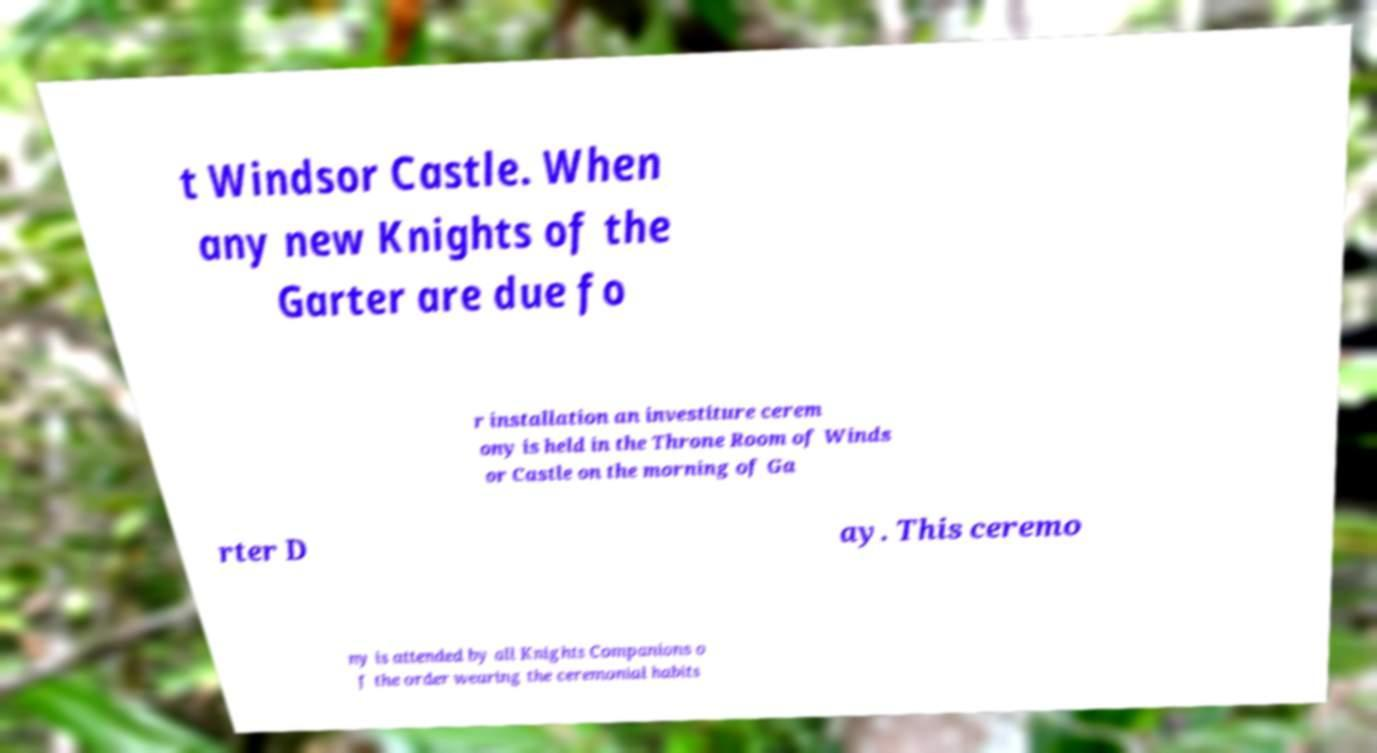Could you extract and type out the text from this image? t Windsor Castle. When any new Knights of the Garter are due fo r installation an investiture cerem ony is held in the Throne Room of Winds or Castle on the morning of Ga rter D ay. This ceremo ny is attended by all Knights Companions o f the order wearing the ceremonial habits 